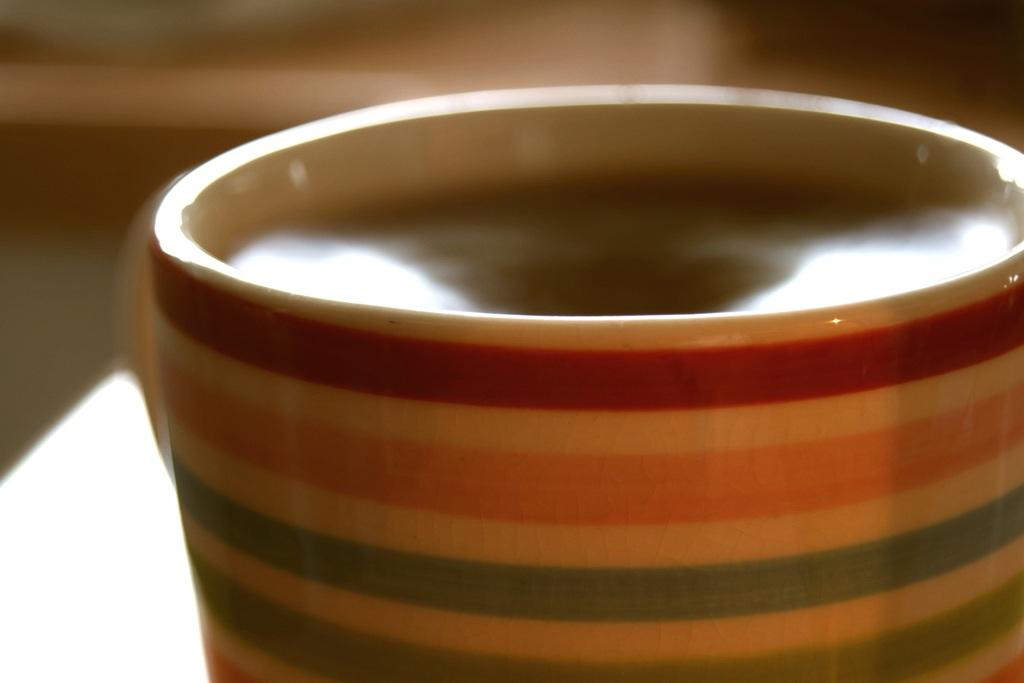What object is present in the image that can hold a liquid? There is a cup in the image that can hold a liquid. How is the cup depicted in the image? The cup is truncated towards the bottom of the image. What is inside the cup? There is a drink in the cup. Can you describe the background of the image? The background of the image is blurred. What type of relation is depicted between the cup and the bucket in the image? There is no bucket present in the image, so there is no relation between the cup and a bucket. 